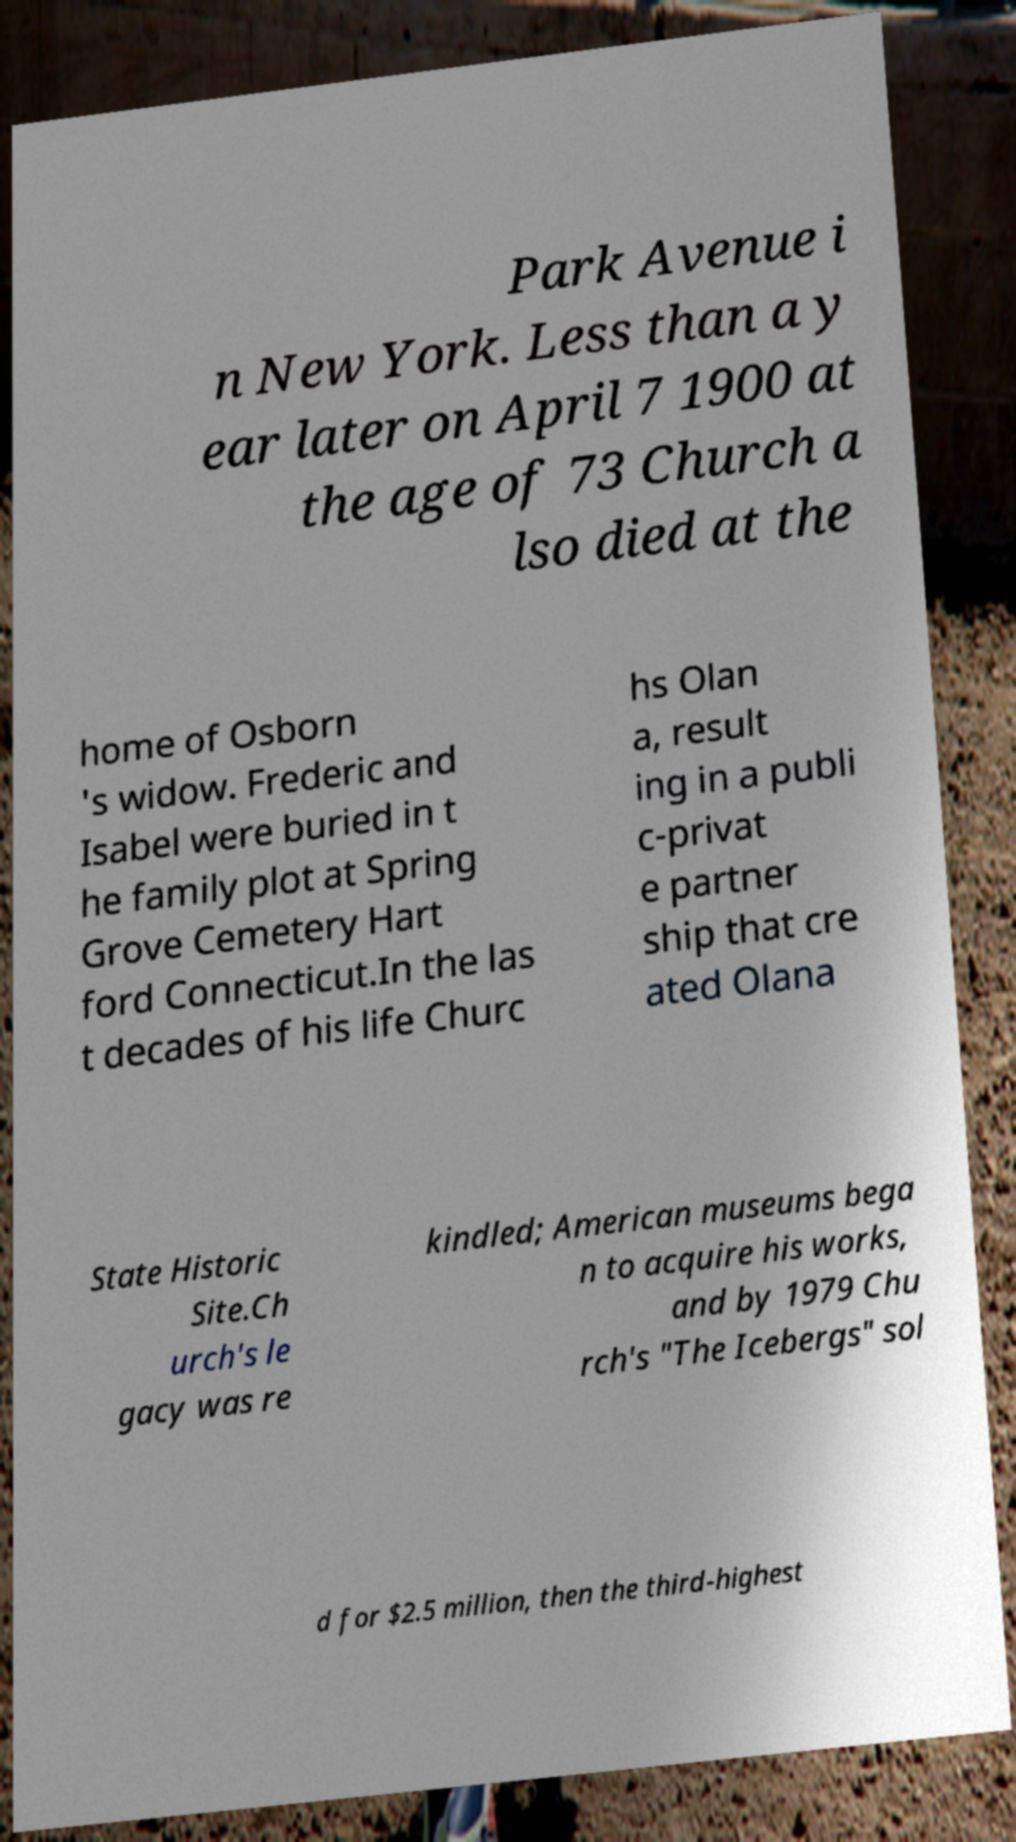There's text embedded in this image that I need extracted. Can you transcribe it verbatim? Park Avenue i n New York. Less than a y ear later on April 7 1900 at the age of 73 Church a lso died at the home of Osborn 's widow. Frederic and Isabel were buried in t he family plot at Spring Grove Cemetery Hart ford Connecticut.In the las t decades of his life Churc hs Olan a, result ing in a publi c-privat e partner ship that cre ated Olana State Historic Site.Ch urch's le gacy was re kindled; American museums bega n to acquire his works, and by 1979 Chu rch's "The Icebergs" sol d for $2.5 million, then the third-highest 